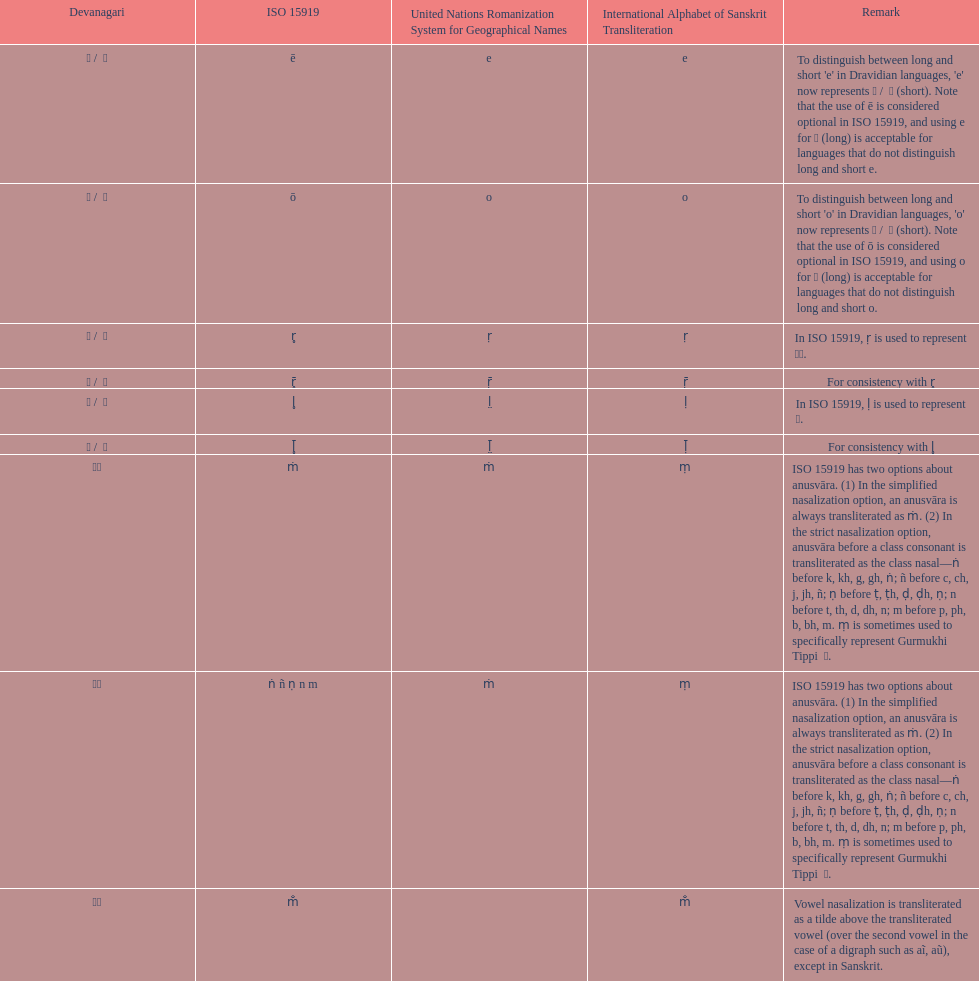Which devanagari transliteration is listed on the top of the table? ए / े. 